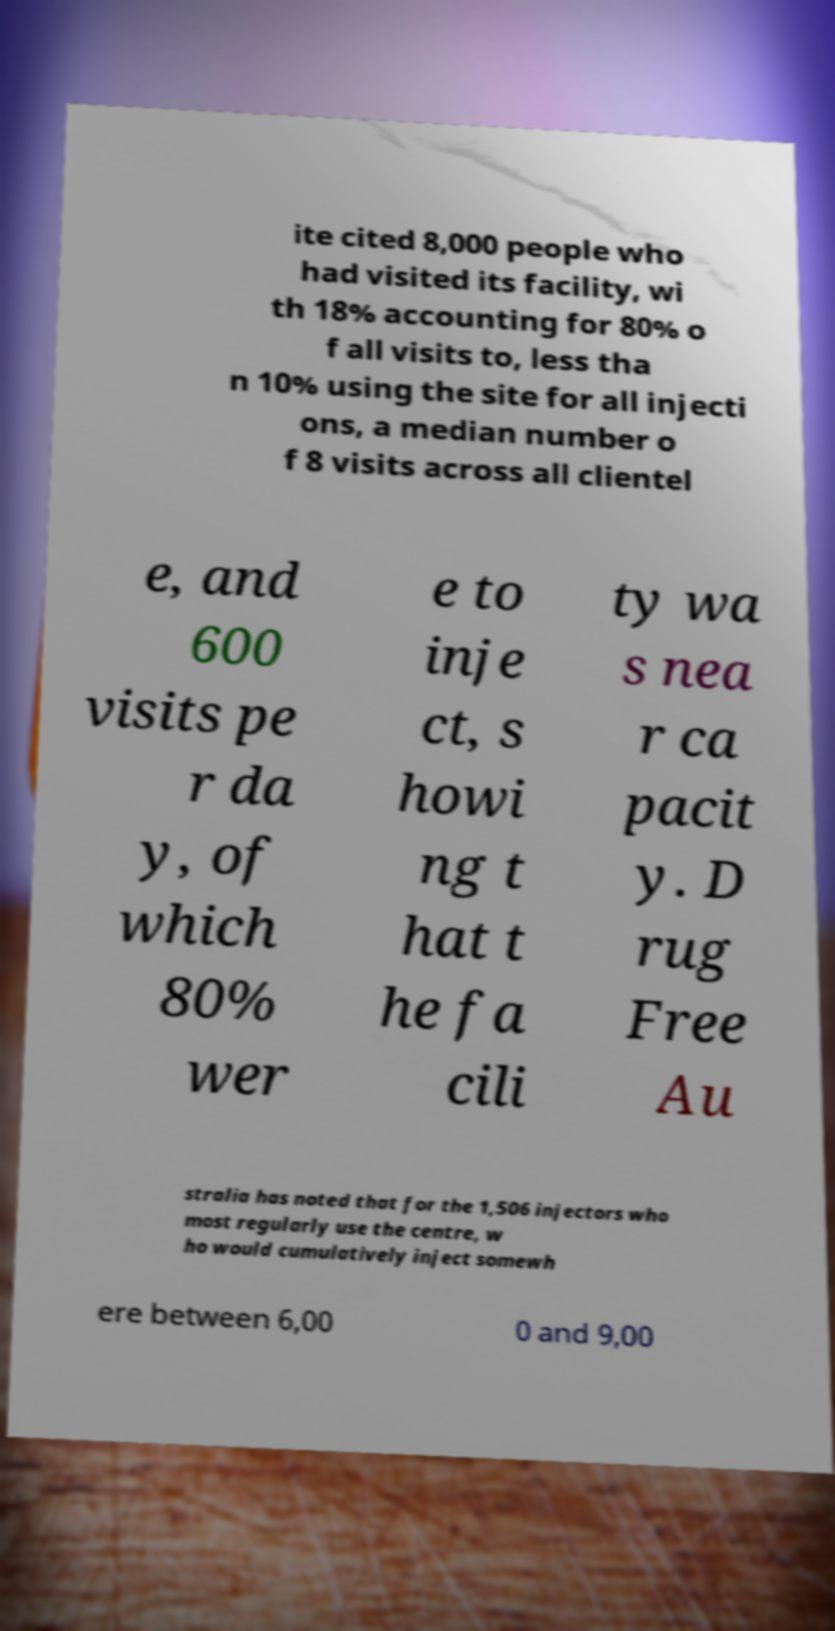Please identify and transcribe the text found in this image. ite cited 8,000 people who had visited its facility, wi th 18% accounting for 80% o f all visits to, less tha n 10% using the site for all injecti ons, a median number o f 8 visits across all clientel e, and 600 visits pe r da y, of which 80% wer e to inje ct, s howi ng t hat t he fa cili ty wa s nea r ca pacit y. D rug Free Au stralia has noted that for the 1,506 injectors who most regularly use the centre, w ho would cumulatively inject somewh ere between 6,00 0 and 9,00 